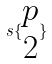Convert formula to latex. <formula><loc_0><loc_0><loc_500><loc_500>s \{ \begin{matrix} p \\ 2 \end{matrix} \}</formula> 